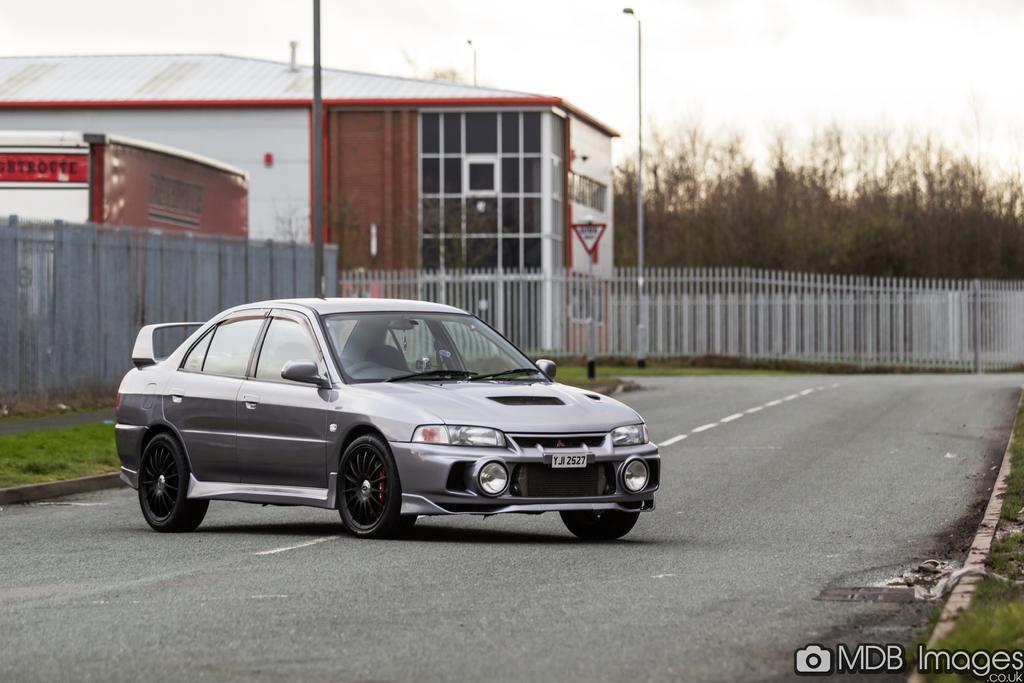Describe this image in one or two sentences. In this picture we can see a car on the road, in the background we can find fence, a house, poles and trees, at the right bottom of the image we can see a watermark. 